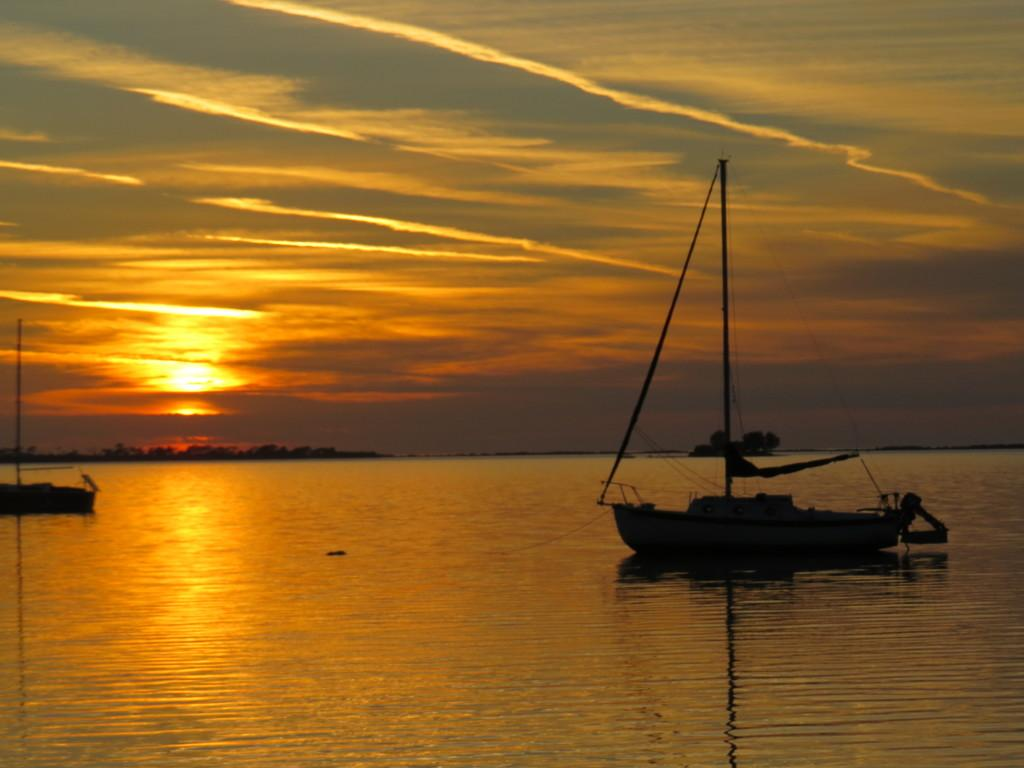What can be seen in the water in the image? There are two boats in the water. What is visible in the background of the image? There are trees in the background of the image. What is visible in the sky at the top of the image? The sun is visible in the sky at the top of the image. Can you see the floor of the water in the image? There is no reference to a floor in the water in the image, as it is a body of water with boats floating on it. 